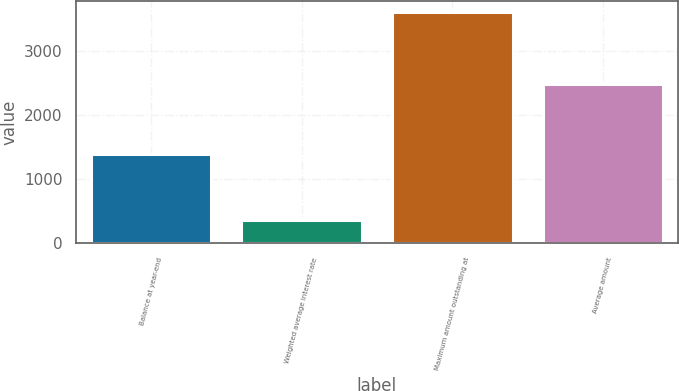Convert chart to OTSL. <chart><loc_0><loc_0><loc_500><loc_500><bar_chart><fcel>Balance at year-end<fcel>Weighted average interest rate<fcel>Maximum amount outstanding at<fcel>Average amount<nl><fcel>1389<fcel>361.1<fcel>3607<fcel>2485<nl></chart> 